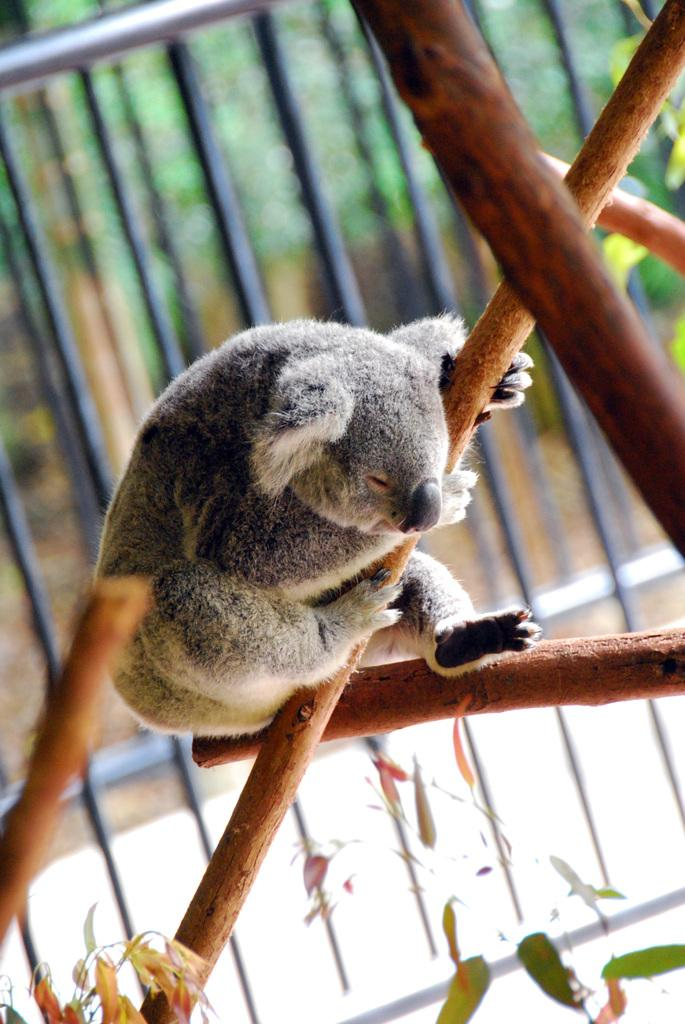What type of animal is in the image? There is an animal in the image, but its specific type cannot be determined from the provided facts. Can you describe the color of the animal? The animal is gray and white in color. What is the animal holding in the image? The animal is holding a stick. What can be seen in the background of the image? There is a railing visible in the background of the image. How does the animal touch the sky in the image? The animal does not touch the sky in the image; there is no indication of the sky being present in the image. 